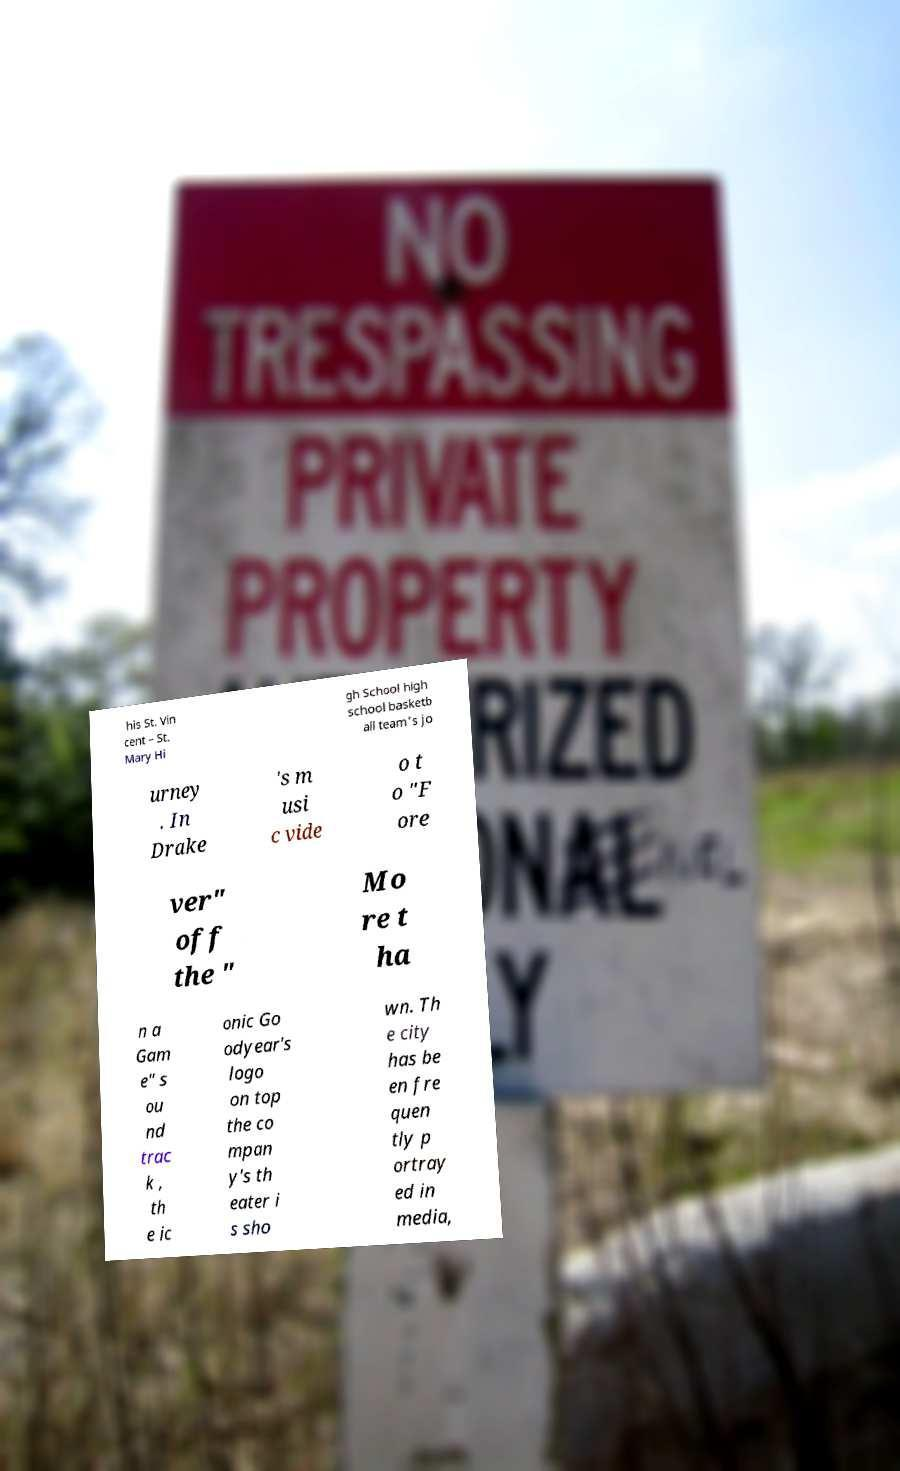Can you accurately transcribe the text from the provided image for me? his St. Vin cent – St. Mary Hi gh School high school basketb all team's jo urney . In Drake 's m usi c vide o t o "F ore ver" off the " Mo re t ha n a Gam e" s ou nd trac k , th e ic onic Go odyear's logo on top the co mpan y's th eater i s sho wn. Th e city has be en fre quen tly p ortray ed in media, 